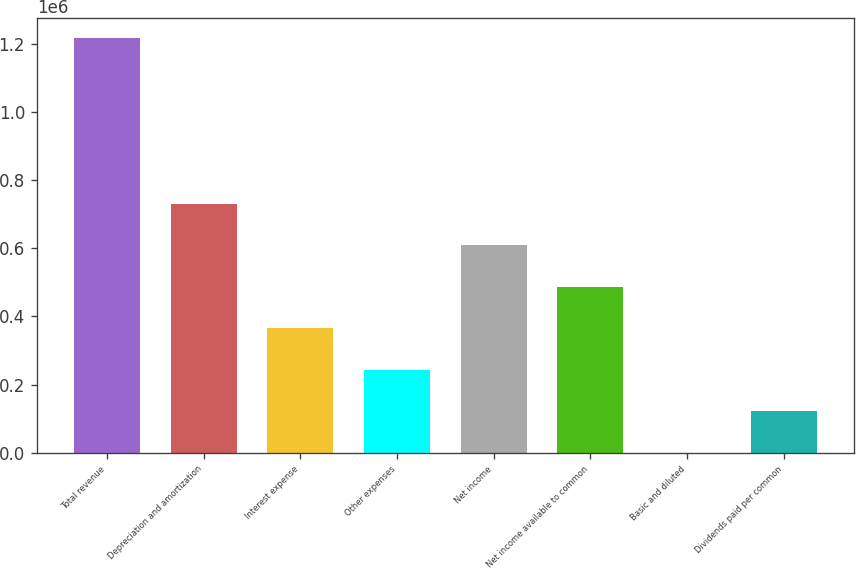<chart> <loc_0><loc_0><loc_500><loc_500><bar_chart><fcel>Total revenue<fcel>Depreciation and amortization<fcel>Interest expense<fcel>Other expenses<fcel>Net income<fcel>Net income available to common<fcel>Basic and diluted<fcel>Dividends paid per common<nl><fcel>1.21577e+06<fcel>729461<fcel>364731<fcel>243154<fcel>607885<fcel>486308<fcel>1.1<fcel>121578<nl></chart> 